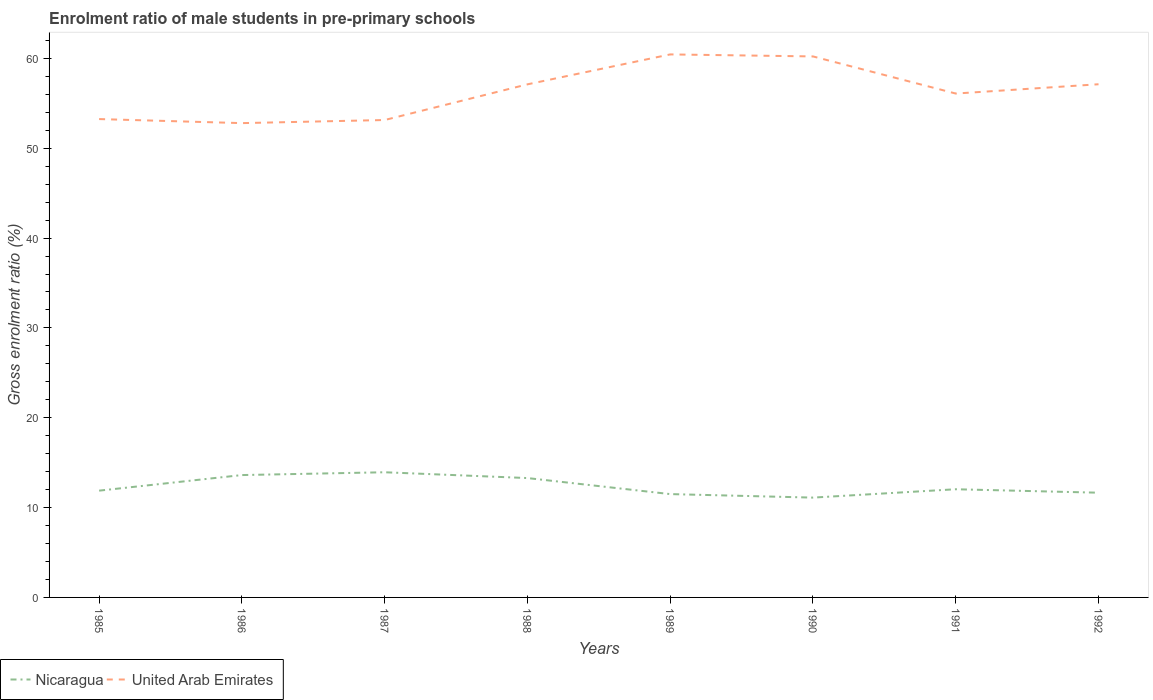Does the line corresponding to United Arab Emirates intersect with the line corresponding to Nicaragua?
Make the answer very short. No. Across all years, what is the maximum enrolment ratio of male students in pre-primary schools in United Arab Emirates?
Keep it short and to the point. 52.8. What is the total enrolment ratio of male students in pre-primary schools in United Arab Emirates in the graph?
Give a very brief answer. -7.3. What is the difference between the highest and the second highest enrolment ratio of male students in pre-primary schools in Nicaragua?
Provide a short and direct response. 2.82. What is the difference between the highest and the lowest enrolment ratio of male students in pre-primary schools in Nicaragua?
Make the answer very short. 3. Is the enrolment ratio of male students in pre-primary schools in Nicaragua strictly greater than the enrolment ratio of male students in pre-primary schools in United Arab Emirates over the years?
Your response must be concise. Yes. What is the difference between two consecutive major ticks on the Y-axis?
Keep it short and to the point. 10. Are the values on the major ticks of Y-axis written in scientific E-notation?
Make the answer very short. No. Does the graph contain any zero values?
Ensure brevity in your answer.  No. Where does the legend appear in the graph?
Your answer should be very brief. Bottom left. How are the legend labels stacked?
Give a very brief answer. Horizontal. What is the title of the graph?
Offer a very short reply. Enrolment ratio of male students in pre-primary schools. What is the label or title of the Y-axis?
Provide a succinct answer. Gross enrolment ratio (%). What is the Gross enrolment ratio (%) of Nicaragua in 1985?
Provide a short and direct response. 11.89. What is the Gross enrolment ratio (%) in United Arab Emirates in 1985?
Your answer should be very brief. 53.25. What is the Gross enrolment ratio (%) of Nicaragua in 1986?
Your answer should be very brief. 13.62. What is the Gross enrolment ratio (%) in United Arab Emirates in 1986?
Offer a very short reply. 52.8. What is the Gross enrolment ratio (%) of Nicaragua in 1987?
Your answer should be very brief. 13.93. What is the Gross enrolment ratio (%) in United Arab Emirates in 1987?
Keep it short and to the point. 53.14. What is the Gross enrolment ratio (%) of Nicaragua in 1988?
Offer a very short reply. 13.29. What is the Gross enrolment ratio (%) in United Arab Emirates in 1988?
Keep it short and to the point. 57.11. What is the Gross enrolment ratio (%) of Nicaragua in 1989?
Make the answer very short. 11.5. What is the Gross enrolment ratio (%) of United Arab Emirates in 1989?
Make the answer very short. 60.44. What is the Gross enrolment ratio (%) in Nicaragua in 1990?
Give a very brief answer. 11.11. What is the Gross enrolment ratio (%) in United Arab Emirates in 1990?
Ensure brevity in your answer.  60.22. What is the Gross enrolment ratio (%) in Nicaragua in 1991?
Your answer should be compact. 12.04. What is the Gross enrolment ratio (%) of United Arab Emirates in 1991?
Provide a short and direct response. 56.09. What is the Gross enrolment ratio (%) of Nicaragua in 1992?
Offer a very short reply. 11.66. What is the Gross enrolment ratio (%) in United Arab Emirates in 1992?
Ensure brevity in your answer.  57.12. Across all years, what is the maximum Gross enrolment ratio (%) of Nicaragua?
Your response must be concise. 13.93. Across all years, what is the maximum Gross enrolment ratio (%) in United Arab Emirates?
Your answer should be very brief. 60.44. Across all years, what is the minimum Gross enrolment ratio (%) in Nicaragua?
Offer a terse response. 11.11. Across all years, what is the minimum Gross enrolment ratio (%) in United Arab Emirates?
Offer a very short reply. 52.8. What is the total Gross enrolment ratio (%) in Nicaragua in the graph?
Provide a short and direct response. 99.04. What is the total Gross enrolment ratio (%) in United Arab Emirates in the graph?
Your answer should be compact. 450.17. What is the difference between the Gross enrolment ratio (%) of Nicaragua in 1985 and that in 1986?
Give a very brief answer. -1.74. What is the difference between the Gross enrolment ratio (%) in United Arab Emirates in 1985 and that in 1986?
Provide a short and direct response. 0.45. What is the difference between the Gross enrolment ratio (%) of Nicaragua in 1985 and that in 1987?
Provide a succinct answer. -2.05. What is the difference between the Gross enrolment ratio (%) in United Arab Emirates in 1985 and that in 1987?
Provide a succinct answer. 0.11. What is the difference between the Gross enrolment ratio (%) in Nicaragua in 1985 and that in 1988?
Provide a short and direct response. -1.4. What is the difference between the Gross enrolment ratio (%) in United Arab Emirates in 1985 and that in 1988?
Provide a short and direct response. -3.87. What is the difference between the Gross enrolment ratio (%) in Nicaragua in 1985 and that in 1989?
Offer a terse response. 0.38. What is the difference between the Gross enrolment ratio (%) in United Arab Emirates in 1985 and that in 1989?
Make the answer very short. -7.2. What is the difference between the Gross enrolment ratio (%) of Nicaragua in 1985 and that in 1990?
Your response must be concise. 0.77. What is the difference between the Gross enrolment ratio (%) in United Arab Emirates in 1985 and that in 1990?
Offer a terse response. -6.97. What is the difference between the Gross enrolment ratio (%) of Nicaragua in 1985 and that in 1991?
Your response must be concise. -0.16. What is the difference between the Gross enrolment ratio (%) of United Arab Emirates in 1985 and that in 1991?
Make the answer very short. -2.84. What is the difference between the Gross enrolment ratio (%) of Nicaragua in 1985 and that in 1992?
Your answer should be compact. 0.23. What is the difference between the Gross enrolment ratio (%) of United Arab Emirates in 1985 and that in 1992?
Your answer should be compact. -3.88. What is the difference between the Gross enrolment ratio (%) of Nicaragua in 1986 and that in 1987?
Your answer should be compact. -0.31. What is the difference between the Gross enrolment ratio (%) in United Arab Emirates in 1986 and that in 1987?
Ensure brevity in your answer.  -0.34. What is the difference between the Gross enrolment ratio (%) in Nicaragua in 1986 and that in 1988?
Provide a short and direct response. 0.33. What is the difference between the Gross enrolment ratio (%) in United Arab Emirates in 1986 and that in 1988?
Your response must be concise. -4.32. What is the difference between the Gross enrolment ratio (%) in Nicaragua in 1986 and that in 1989?
Provide a short and direct response. 2.12. What is the difference between the Gross enrolment ratio (%) of United Arab Emirates in 1986 and that in 1989?
Ensure brevity in your answer.  -7.65. What is the difference between the Gross enrolment ratio (%) in Nicaragua in 1986 and that in 1990?
Your answer should be compact. 2.51. What is the difference between the Gross enrolment ratio (%) in United Arab Emirates in 1986 and that in 1990?
Offer a very short reply. -7.42. What is the difference between the Gross enrolment ratio (%) in Nicaragua in 1986 and that in 1991?
Your response must be concise. 1.58. What is the difference between the Gross enrolment ratio (%) of United Arab Emirates in 1986 and that in 1991?
Give a very brief answer. -3.29. What is the difference between the Gross enrolment ratio (%) in Nicaragua in 1986 and that in 1992?
Offer a terse response. 1.96. What is the difference between the Gross enrolment ratio (%) in United Arab Emirates in 1986 and that in 1992?
Provide a succinct answer. -4.33. What is the difference between the Gross enrolment ratio (%) in Nicaragua in 1987 and that in 1988?
Give a very brief answer. 0.65. What is the difference between the Gross enrolment ratio (%) of United Arab Emirates in 1987 and that in 1988?
Your answer should be very brief. -3.97. What is the difference between the Gross enrolment ratio (%) in Nicaragua in 1987 and that in 1989?
Your answer should be compact. 2.43. What is the difference between the Gross enrolment ratio (%) of United Arab Emirates in 1987 and that in 1989?
Ensure brevity in your answer.  -7.3. What is the difference between the Gross enrolment ratio (%) in Nicaragua in 1987 and that in 1990?
Keep it short and to the point. 2.82. What is the difference between the Gross enrolment ratio (%) in United Arab Emirates in 1987 and that in 1990?
Keep it short and to the point. -7.08. What is the difference between the Gross enrolment ratio (%) of Nicaragua in 1987 and that in 1991?
Offer a very short reply. 1.89. What is the difference between the Gross enrolment ratio (%) in United Arab Emirates in 1987 and that in 1991?
Provide a succinct answer. -2.95. What is the difference between the Gross enrolment ratio (%) in Nicaragua in 1987 and that in 1992?
Make the answer very short. 2.28. What is the difference between the Gross enrolment ratio (%) in United Arab Emirates in 1987 and that in 1992?
Ensure brevity in your answer.  -3.98. What is the difference between the Gross enrolment ratio (%) of Nicaragua in 1988 and that in 1989?
Provide a short and direct response. 1.78. What is the difference between the Gross enrolment ratio (%) in United Arab Emirates in 1988 and that in 1989?
Offer a terse response. -3.33. What is the difference between the Gross enrolment ratio (%) of Nicaragua in 1988 and that in 1990?
Your response must be concise. 2.18. What is the difference between the Gross enrolment ratio (%) in United Arab Emirates in 1988 and that in 1990?
Keep it short and to the point. -3.11. What is the difference between the Gross enrolment ratio (%) of Nicaragua in 1988 and that in 1991?
Offer a very short reply. 1.24. What is the difference between the Gross enrolment ratio (%) in United Arab Emirates in 1988 and that in 1991?
Give a very brief answer. 1.02. What is the difference between the Gross enrolment ratio (%) in Nicaragua in 1988 and that in 1992?
Your answer should be very brief. 1.63. What is the difference between the Gross enrolment ratio (%) of United Arab Emirates in 1988 and that in 1992?
Your response must be concise. -0.01. What is the difference between the Gross enrolment ratio (%) of Nicaragua in 1989 and that in 1990?
Make the answer very short. 0.39. What is the difference between the Gross enrolment ratio (%) of United Arab Emirates in 1989 and that in 1990?
Your answer should be compact. 0.22. What is the difference between the Gross enrolment ratio (%) of Nicaragua in 1989 and that in 1991?
Your response must be concise. -0.54. What is the difference between the Gross enrolment ratio (%) of United Arab Emirates in 1989 and that in 1991?
Your response must be concise. 4.36. What is the difference between the Gross enrolment ratio (%) in Nicaragua in 1989 and that in 1992?
Provide a short and direct response. -0.16. What is the difference between the Gross enrolment ratio (%) in United Arab Emirates in 1989 and that in 1992?
Make the answer very short. 3.32. What is the difference between the Gross enrolment ratio (%) of Nicaragua in 1990 and that in 1991?
Provide a short and direct response. -0.93. What is the difference between the Gross enrolment ratio (%) of United Arab Emirates in 1990 and that in 1991?
Your answer should be compact. 4.13. What is the difference between the Gross enrolment ratio (%) of Nicaragua in 1990 and that in 1992?
Provide a succinct answer. -0.55. What is the difference between the Gross enrolment ratio (%) in United Arab Emirates in 1990 and that in 1992?
Provide a succinct answer. 3.1. What is the difference between the Gross enrolment ratio (%) of Nicaragua in 1991 and that in 1992?
Your response must be concise. 0.39. What is the difference between the Gross enrolment ratio (%) of United Arab Emirates in 1991 and that in 1992?
Your answer should be very brief. -1.03. What is the difference between the Gross enrolment ratio (%) of Nicaragua in 1985 and the Gross enrolment ratio (%) of United Arab Emirates in 1986?
Your response must be concise. -40.91. What is the difference between the Gross enrolment ratio (%) in Nicaragua in 1985 and the Gross enrolment ratio (%) in United Arab Emirates in 1987?
Provide a succinct answer. -41.26. What is the difference between the Gross enrolment ratio (%) in Nicaragua in 1985 and the Gross enrolment ratio (%) in United Arab Emirates in 1988?
Offer a terse response. -45.23. What is the difference between the Gross enrolment ratio (%) of Nicaragua in 1985 and the Gross enrolment ratio (%) of United Arab Emirates in 1989?
Make the answer very short. -48.56. What is the difference between the Gross enrolment ratio (%) of Nicaragua in 1985 and the Gross enrolment ratio (%) of United Arab Emirates in 1990?
Your response must be concise. -48.33. What is the difference between the Gross enrolment ratio (%) in Nicaragua in 1985 and the Gross enrolment ratio (%) in United Arab Emirates in 1991?
Your response must be concise. -44.2. What is the difference between the Gross enrolment ratio (%) of Nicaragua in 1985 and the Gross enrolment ratio (%) of United Arab Emirates in 1992?
Provide a short and direct response. -45.24. What is the difference between the Gross enrolment ratio (%) in Nicaragua in 1986 and the Gross enrolment ratio (%) in United Arab Emirates in 1987?
Ensure brevity in your answer.  -39.52. What is the difference between the Gross enrolment ratio (%) of Nicaragua in 1986 and the Gross enrolment ratio (%) of United Arab Emirates in 1988?
Provide a short and direct response. -43.49. What is the difference between the Gross enrolment ratio (%) of Nicaragua in 1986 and the Gross enrolment ratio (%) of United Arab Emirates in 1989?
Provide a short and direct response. -46.82. What is the difference between the Gross enrolment ratio (%) in Nicaragua in 1986 and the Gross enrolment ratio (%) in United Arab Emirates in 1990?
Give a very brief answer. -46.6. What is the difference between the Gross enrolment ratio (%) of Nicaragua in 1986 and the Gross enrolment ratio (%) of United Arab Emirates in 1991?
Give a very brief answer. -42.47. What is the difference between the Gross enrolment ratio (%) of Nicaragua in 1986 and the Gross enrolment ratio (%) of United Arab Emirates in 1992?
Ensure brevity in your answer.  -43.5. What is the difference between the Gross enrolment ratio (%) of Nicaragua in 1987 and the Gross enrolment ratio (%) of United Arab Emirates in 1988?
Give a very brief answer. -43.18. What is the difference between the Gross enrolment ratio (%) of Nicaragua in 1987 and the Gross enrolment ratio (%) of United Arab Emirates in 1989?
Give a very brief answer. -46.51. What is the difference between the Gross enrolment ratio (%) in Nicaragua in 1987 and the Gross enrolment ratio (%) in United Arab Emirates in 1990?
Keep it short and to the point. -46.29. What is the difference between the Gross enrolment ratio (%) of Nicaragua in 1987 and the Gross enrolment ratio (%) of United Arab Emirates in 1991?
Provide a short and direct response. -42.16. What is the difference between the Gross enrolment ratio (%) of Nicaragua in 1987 and the Gross enrolment ratio (%) of United Arab Emirates in 1992?
Your answer should be compact. -43.19. What is the difference between the Gross enrolment ratio (%) of Nicaragua in 1988 and the Gross enrolment ratio (%) of United Arab Emirates in 1989?
Your answer should be very brief. -47.16. What is the difference between the Gross enrolment ratio (%) in Nicaragua in 1988 and the Gross enrolment ratio (%) in United Arab Emirates in 1990?
Give a very brief answer. -46.93. What is the difference between the Gross enrolment ratio (%) of Nicaragua in 1988 and the Gross enrolment ratio (%) of United Arab Emirates in 1991?
Give a very brief answer. -42.8. What is the difference between the Gross enrolment ratio (%) in Nicaragua in 1988 and the Gross enrolment ratio (%) in United Arab Emirates in 1992?
Your response must be concise. -43.84. What is the difference between the Gross enrolment ratio (%) in Nicaragua in 1989 and the Gross enrolment ratio (%) in United Arab Emirates in 1990?
Provide a succinct answer. -48.72. What is the difference between the Gross enrolment ratio (%) in Nicaragua in 1989 and the Gross enrolment ratio (%) in United Arab Emirates in 1991?
Ensure brevity in your answer.  -44.59. What is the difference between the Gross enrolment ratio (%) in Nicaragua in 1989 and the Gross enrolment ratio (%) in United Arab Emirates in 1992?
Keep it short and to the point. -45.62. What is the difference between the Gross enrolment ratio (%) in Nicaragua in 1990 and the Gross enrolment ratio (%) in United Arab Emirates in 1991?
Your response must be concise. -44.98. What is the difference between the Gross enrolment ratio (%) of Nicaragua in 1990 and the Gross enrolment ratio (%) of United Arab Emirates in 1992?
Provide a succinct answer. -46.01. What is the difference between the Gross enrolment ratio (%) in Nicaragua in 1991 and the Gross enrolment ratio (%) in United Arab Emirates in 1992?
Your response must be concise. -45.08. What is the average Gross enrolment ratio (%) of Nicaragua per year?
Provide a short and direct response. 12.38. What is the average Gross enrolment ratio (%) in United Arab Emirates per year?
Provide a short and direct response. 56.27. In the year 1985, what is the difference between the Gross enrolment ratio (%) in Nicaragua and Gross enrolment ratio (%) in United Arab Emirates?
Offer a very short reply. -41.36. In the year 1986, what is the difference between the Gross enrolment ratio (%) in Nicaragua and Gross enrolment ratio (%) in United Arab Emirates?
Ensure brevity in your answer.  -39.18. In the year 1987, what is the difference between the Gross enrolment ratio (%) in Nicaragua and Gross enrolment ratio (%) in United Arab Emirates?
Your answer should be very brief. -39.21. In the year 1988, what is the difference between the Gross enrolment ratio (%) of Nicaragua and Gross enrolment ratio (%) of United Arab Emirates?
Make the answer very short. -43.83. In the year 1989, what is the difference between the Gross enrolment ratio (%) in Nicaragua and Gross enrolment ratio (%) in United Arab Emirates?
Provide a succinct answer. -48.94. In the year 1990, what is the difference between the Gross enrolment ratio (%) of Nicaragua and Gross enrolment ratio (%) of United Arab Emirates?
Your answer should be compact. -49.11. In the year 1991, what is the difference between the Gross enrolment ratio (%) in Nicaragua and Gross enrolment ratio (%) in United Arab Emirates?
Keep it short and to the point. -44.05. In the year 1992, what is the difference between the Gross enrolment ratio (%) of Nicaragua and Gross enrolment ratio (%) of United Arab Emirates?
Provide a short and direct response. -45.47. What is the ratio of the Gross enrolment ratio (%) in Nicaragua in 1985 to that in 1986?
Your response must be concise. 0.87. What is the ratio of the Gross enrolment ratio (%) of United Arab Emirates in 1985 to that in 1986?
Your answer should be compact. 1.01. What is the ratio of the Gross enrolment ratio (%) of Nicaragua in 1985 to that in 1987?
Ensure brevity in your answer.  0.85. What is the ratio of the Gross enrolment ratio (%) in Nicaragua in 1985 to that in 1988?
Offer a very short reply. 0.89. What is the ratio of the Gross enrolment ratio (%) of United Arab Emirates in 1985 to that in 1988?
Keep it short and to the point. 0.93. What is the ratio of the Gross enrolment ratio (%) in Nicaragua in 1985 to that in 1989?
Offer a terse response. 1.03. What is the ratio of the Gross enrolment ratio (%) in United Arab Emirates in 1985 to that in 1989?
Provide a short and direct response. 0.88. What is the ratio of the Gross enrolment ratio (%) in Nicaragua in 1985 to that in 1990?
Keep it short and to the point. 1.07. What is the ratio of the Gross enrolment ratio (%) in United Arab Emirates in 1985 to that in 1990?
Your answer should be very brief. 0.88. What is the ratio of the Gross enrolment ratio (%) in Nicaragua in 1985 to that in 1991?
Provide a short and direct response. 0.99. What is the ratio of the Gross enrolment ratio (%) in United Arab Emirates in 1985 to that in 1991?
Ensure brevity in your answer.  0.95. What is the ratio of the Gross enrolment ratio (%) of Nicaragua in 1985 to that in 1992?
Make the answer very short. 1.02. What is the ratio of the Gross enrolment ratio (%) in United Arab Emirates in 1985 to that in 1992?
Your response must be concise. 0.93. What is the ratio of the Gross enrolment ratio (%) in Nicaragua in 1986 to that in 1987?
Your response must be concise. 0.98. What is the ratio of the Gross enrolment ratio (%) of United Arab Emirates in 1986 to that in 1987?
Provide a short and direct response. 0.99. What is the ratio of the Gross enrolment ratio (%) in Nicaragua in 1986 to that in 1988?
Your answer should be very brief. 1.03. What is the ratio of the Gross enrolment ratio (%) in United Arab Emirates in 1986 to that in 1988?
Offer a terse response. 0.92. What is the ratio of the Gross enrolment ratio (%) of Nicaragua in 1986 to that in 1989?
Provide a short and direct response. 1.18. What is the ratio of the Gross enrolment ratio (%) of United Arab Emirates in 1986 to that in 1989?
Provide a short and direct response. 0.87. What is the ratio of the Gross enrolment ratio (%) of Nicaragua in 1986 to that in 1990?
Provide a succinct answer. 1.23. What is the ratio of the Gross enrolment ratio (%) of United Arab Emirates in 1986 to that in 1990?
Offer a terse response. 0.88. What is the ratio of the Gross enrolment ratio (%) of Nicaragua in 1986 to that in 1991?
Offer a very short reply. 1.13. What is the ratio of the Gross enrolment ratio (%) in United Arab Emirates in 1986 to that in 1991?
Provide a short and direct response. 0.94. What is the ratio of the Gross enrolment ratio (%) of Nicaragua in 1986 to that in 1992?
Offer a very short reply. 1.17. What is the ratio of the Gross enrolment ratio (%) in United Arab Emirates in 1986 to that in 1992?
Your answer should be very brief. 0.92. What is the ratio of the Gross enrolment ratio (%) in Nicaragua in 1987 to that in 1988?
Your response must be concise. 1.05. What is the ratio of the Gross enrolment ratio (%) of United Arab Emirates in 1987 to that in 1988?
Offer a terse response. 0.93. What is the ratio of the Gross enrolment ratio (%) of Nicaragua in 1987 to that in 1989?
Keep it short and to the point. 1.21. What is the ratio of the Gross enrolment ratio (%) of United Arab Emirates in 1987 to that in 1989?
Give a very brief answer. 0.88. What is the ratio of the Gross enrolment ratio (%) in Nicaragua in 1987 to that in 1990?
Your response must be concise. 1.25. What is the ratio of the Gross enrolment ratio (%) in United Arab Emirates in 1987 to that in 1990?
Your answer should be compact. 0.88. What is the ratio of the Gross enrolment ratio (%) of Nicaragua in 1987 to that in 1991?
Offer a very short reply. 1.16. What is the ratio of the Gross enrolment ratio (%) in United Arab Emirates in 1987 to that in 1991?
Keep it short and to the point. 0.95. What is the ratio of the Gross enrolment ratio (%) of Nicaragua in 1987 to that in 1992?
Your response must be concise. 1.2. What is the ratio of the Gross enrolment ratio (%) in United Arab Emirates in 1987 to that in 1992?
Give a very brief answer. 0.93. What is the ratio of the Gross enrolment ratio (%) of Nicaragua in 1988 to that in 1989?
Your response must be concise. 1.16. What is the ratio of the Gross enrolment ratio (%) in United Arab Emirates in 1988 to that in 1989?
Ensure brevity in your answer.  0.94. What is the ratio of the Gross enrolment ratio (%) in Nicaragua in 1988 to that in 1990?
Your answer should be compact. 1.2. What is the ratio of the Gross enrolment ratio (%) in United Arab Emirates in 1988 to that in 1990?
Keep it short and to the point. 0.95. What is the ratio of the Gross enrolment ratio (%) in Nicaragua in 1988 to that in 1991?
Give a very brief answer. 1.1. What is the ratio of the Gross enrolment ratio (%) in United Arab Emirates in 1988 to that in 1991?
Keep it short and to the point. 1.02. What is the ratio of the Gross enrolment ratio (%) of Nicaragua in 1988 to that in 1992?
Make the answer very short. 1.14. What is the ratio of the Gross enrolment ratio (%) in Nicaragua in 1989 to that in 1990?
Keep it short and to the point. 1.04. What is the ratio of the Gross enrolment ratio (%) in Nicaragua in 1989 to that in 1991?
Keep it short and to the point. 0.96. What is the ratio of the Gross enrolment ratio (%) of United Arab Emirates in 1989 to that in 1991?
Your answer should be compact. 1.08. What is the ratio of the Gross enrolment ratio (%) of Nicaragua in 1989 to that in 1992?
Keep it short and to the point. 0.99. What is the ratio of the Gross enrolment ratio (%) of United Arab Emirates in 1989 to that in 1992?
Offer a terse response. 1.06. What is the ratio of the Gross enrolment ratio (%) of Nicaragua in 1990 to that in 1991?
Keep it short and to the point. 0.92. What is the ratio of the Gross enrolment ratio (%) in United Arab Emirates in 1990 to that in 1991?
Your answer should be very brief. 1.07. What is the ratio of the Gross enrolment ratio (%) of Nicaragua in 1990 to that in 1992?
Ensure brevity in your answer.  0.95. What is the ratio of the Gross enrolment ratio (%) of United Arab Emirates in 1990 to that in 1992?
Provide a short and direct response. 1.05. What is the ratio of the Gross enrolment ratio (%) in Nicaragua in 1991 to that in 1992?
Your answer should be very brief. 1.03. What is the ratio of the Gross enrolment ratio (%) of United Arab Emirates in 1991 to that in 1992?
Provide a succinct answer. 0.98. What is the difference between the highest and the second highest Gross enrolment ratio (%) of Nicaragua?
Make the answer very short. 0.31. What is the difference between the highest and the second highest Gross enrolment ratio (%) of United Arab Emirates?
Make the answer very short. 0.22. What is the difference between the highest and the lowest Gross enrolment ratio (%) in Nicaragua?
Keep it short and to the point. 2.82. What is the difference between the highest and the lowest Gross enrolment ratio (%) of United Arab Emirates?
Provide a short and direct response. 7.65. 